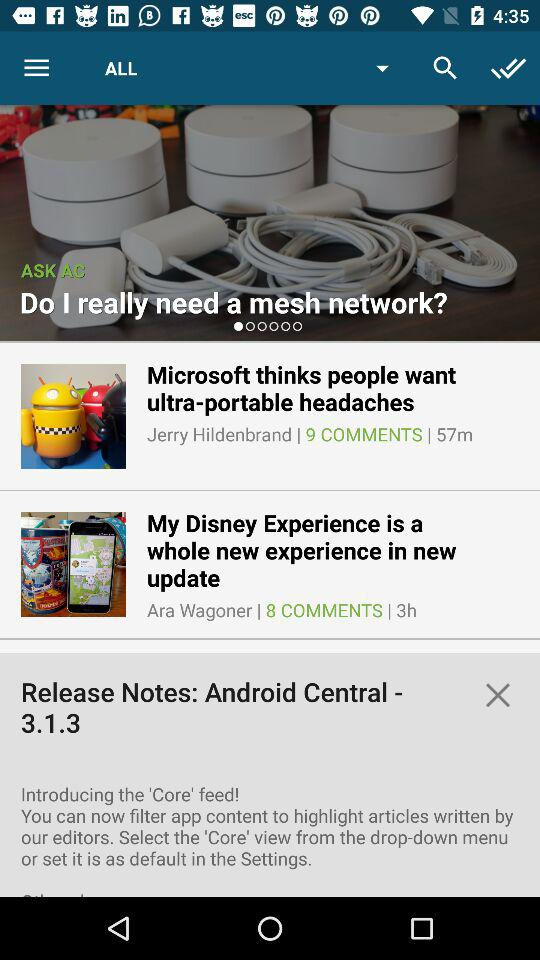How many more comments does the article about Microsoft have than the article about Disney?
Answer the question using a single word or phrase. 1 